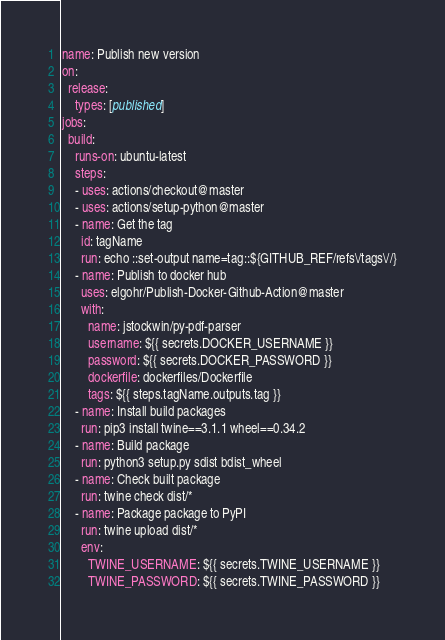Convert code to text. <code><loc_0><loc_0><loc_500><loc_500><_YAML_>name: Publish new version
on:
  release:
    types: [published]
jobs:
  build:
    runs-on: ubuntu-latest
    steps:
    - uses: actions/checkout@master
    - uses: actions/setup-python@master
    - name: Get the tag
      id: tagName
      run: echo ::set-output name=tag::${GITHUB_REF/refs\/tags\//}
    - name: Publish to docker hub
      uses: elgohr/Publish-Docker-Github-Action@master
      with:
        name: jstockwin/py-pdf-parser
        username: ${{ secrets.DOCKER_USERNAME }}
        password: ${{ secrets.DOCKER_PASSWORD }}
        dockerfile: dockerfiles/Dockerfile
        tags: ${{ steps.tagName.outputs.tag }}
    - name: Install build packages
      run: pip3 install twine==3.1.1 wheel==0.34.2
    - name: Build package
      run: python3 setup.py sdist bdist_wheel
    - name: Check built package
      run: twine check dist/*
    - name: Package package to PyPI
      run: twine upload dist/*
      env:
        TWINE_USERNAME: ${{ secrets.TWINE_USERNAME }}
        TWINE_PASSWORD: ${{ secrets.TWINE_PASSWORD }}
</code> 